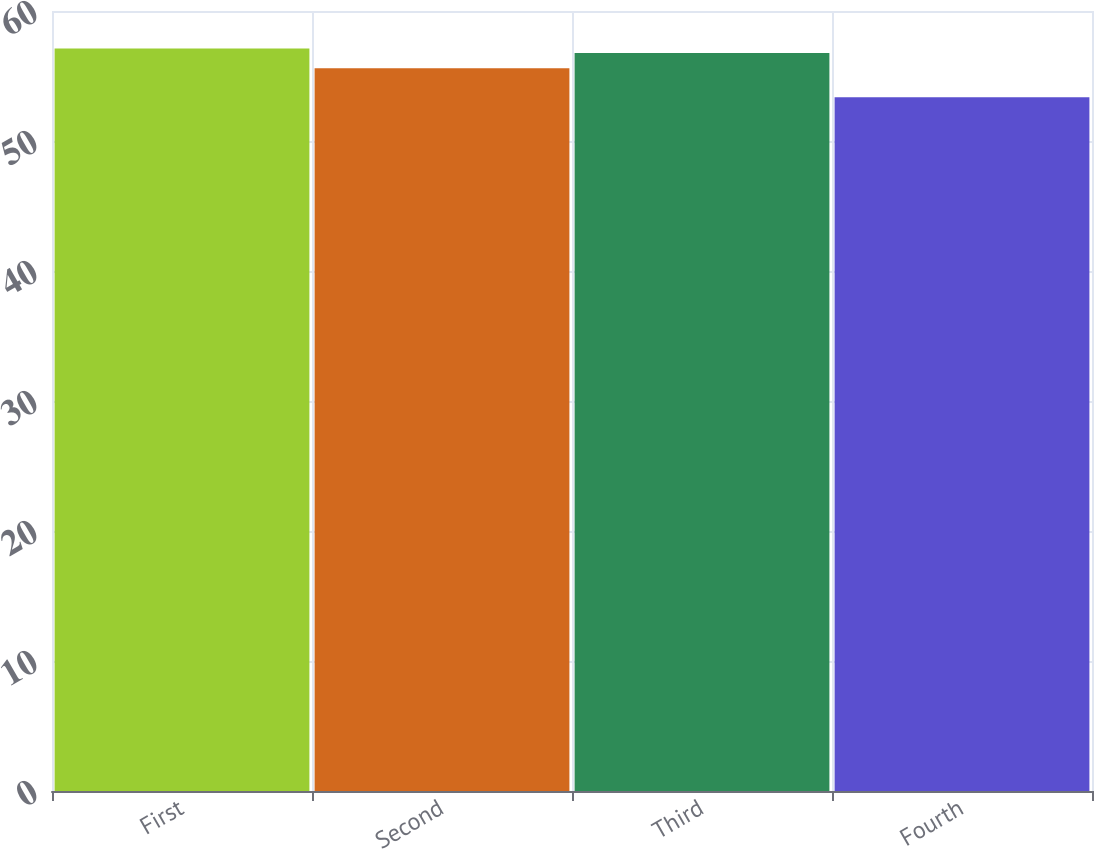Convert chart to OTSL. <chart><loc_0><loc_0><loc_500><loc_500><bar_chart><fcel>First<fcel>Second<fcel>Third<fcel>Fourth<nl><fcel>57.11<fcel>55.6<fcel>56.76<fcel>53.36<nl></chart> 